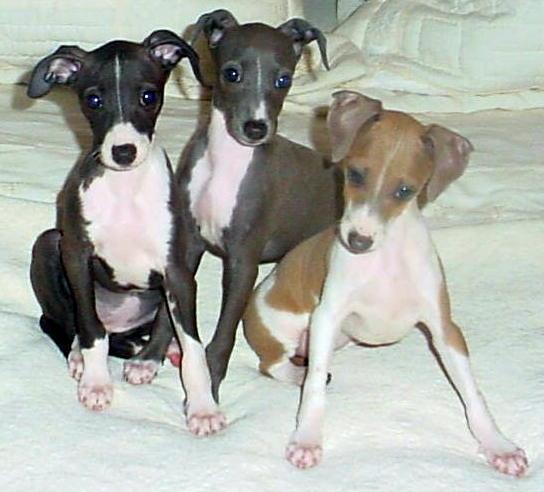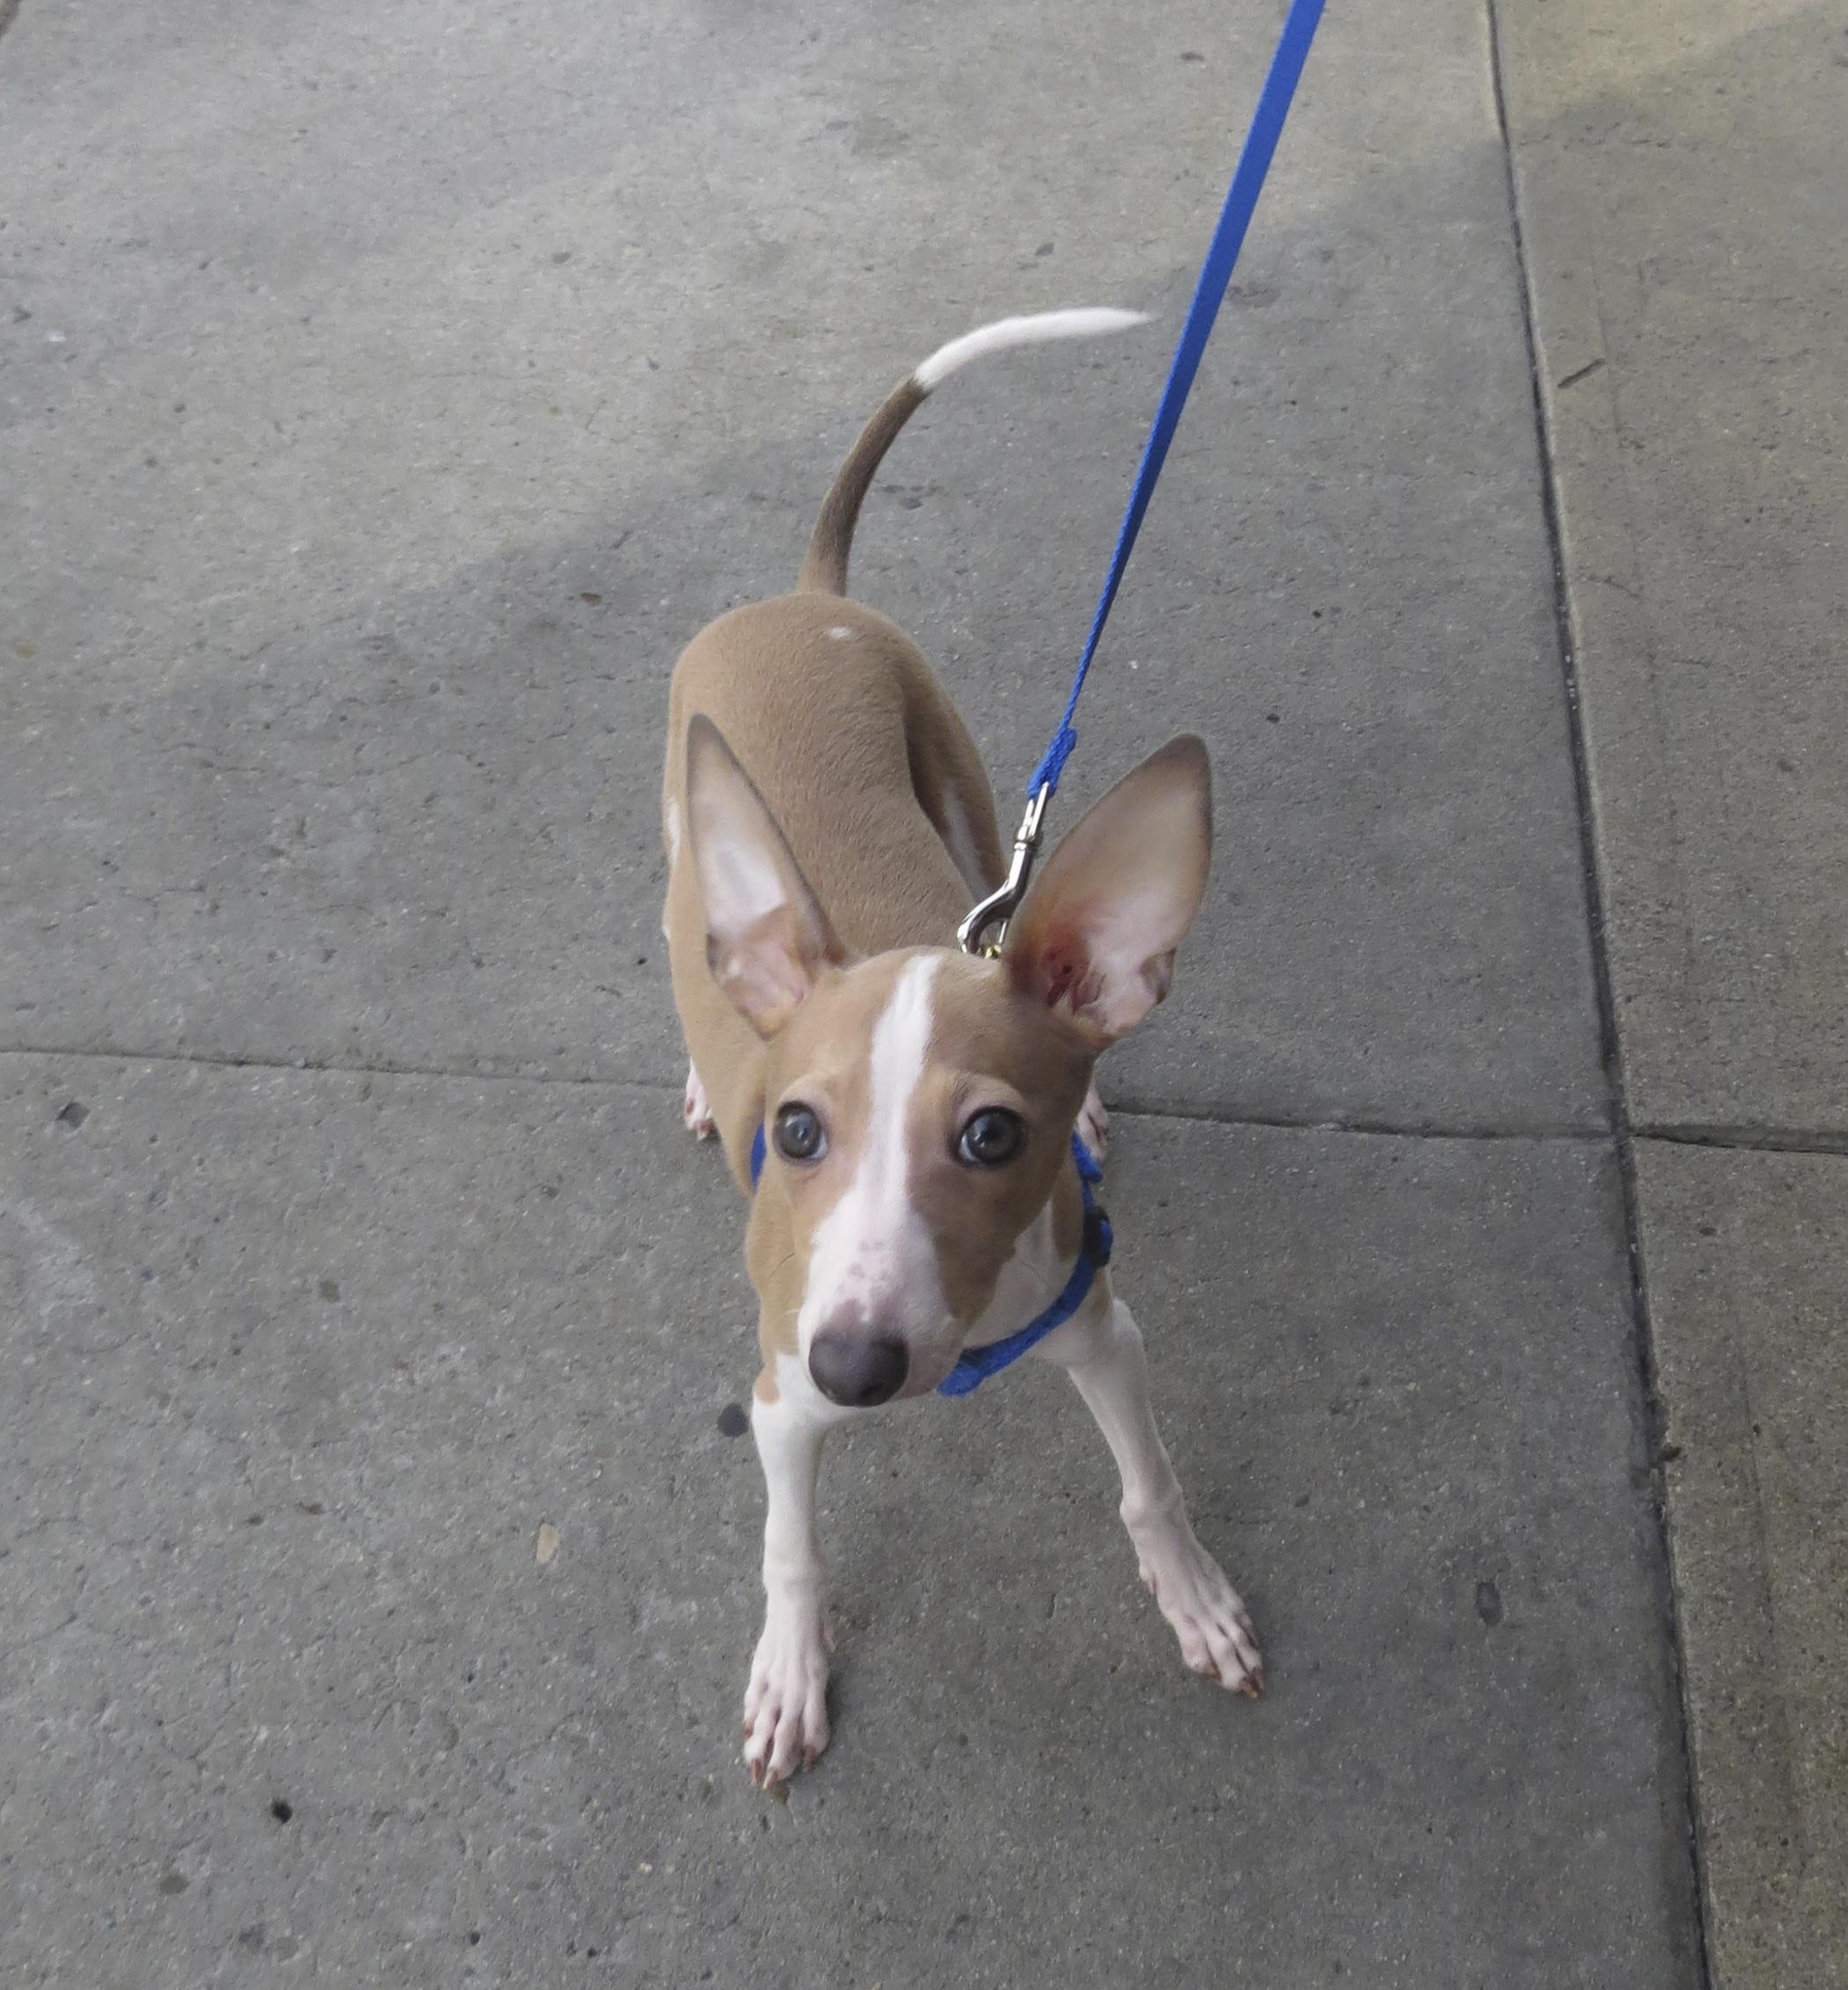The first image is the image on the left, the second image is the image on the right. Analyze the images presented: Is the assertion "Left image contains two standing dogs, and right image contains one non-standing dog." valid? Answer yes or no. No. The first image is the image on the left, the second image is the image on the right. For the images shown, is this caption "There are three dogs shown." true? Answer yes or no. No. 